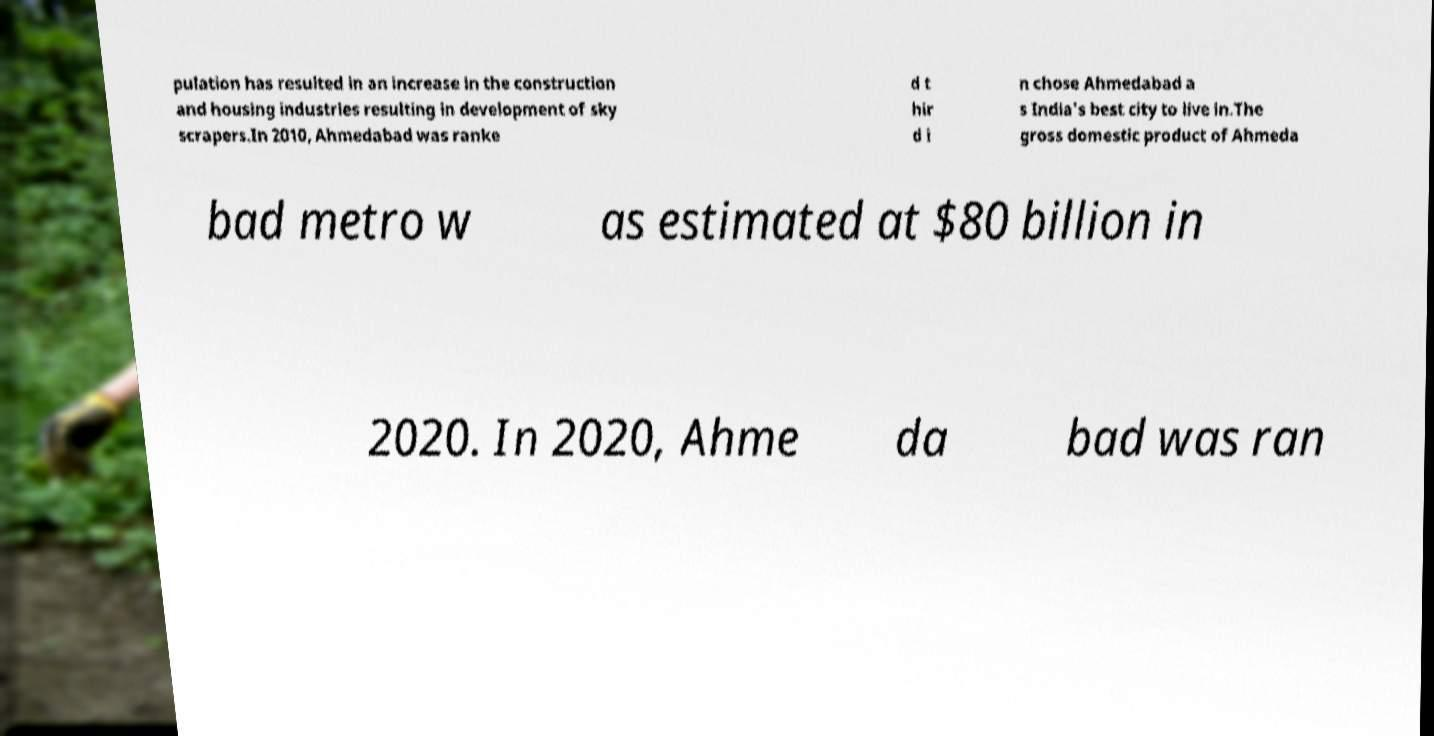Please read and relay the text visible in this image. What does it say? pulation has resulted in an increase in the construction and housing industries resulting in development of sky scrapers.In 2010, Ahmedabad was ranke d t hir d i n chose Ahmedabad a s India's best city to live in.The gross domestic product of Ahmeda bad metro w as estimated at $80 billion in 2020. In 2020, Ahme da bad was ran 